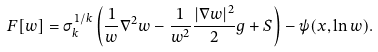<formula> <loc_0><loc_0><loc_500><loc_500>F [ w ] = \sigma _ { k } ^ { 1 / k } \left ( \frac { 1 } { w } \nabla ^ { 2 } w - \frac { 1 } { w ^ { 2 } } \frac { | \nabla w | ^ { 2 } } { 2 } g + S \right ) - \psi ( x , \ln w ) .</formula> 